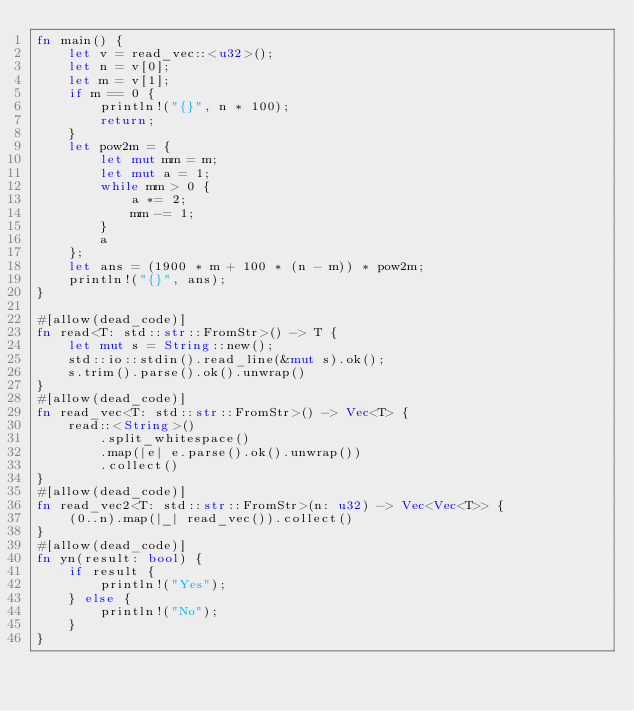Convert code to text. <code><loc_0><loc_0><loc_500><loc_500><_Rust_>fn main() {
    let v = read_vec::<u32>();
    let n = v[0];
    let m = v[1];
    if m == 0 {
        println!("{}", n * 100);
        return;
    }
    let pow2m = {
        let mut mm = m;
        let mut a = 1;
        while mm > 0 {
            a *= 2;
            mm -= 1;
        }
        a
    };
    let ans = (1900 * m + 100 * (n - m)) * pow2m;
    println!("{}", ans);
}

#[allow(dead_code)]
fn read<T: std::str::FromStr>() -> T {
    let mut s = String::new();
    std::io::stdin().read_line(&mut s).ok();
    s.trim().parse().ok().unwrap()
}
#[allow(dead_code)]
fn read_vec<T: std::str::FromStr>() -> Vec<T> {
    read::<String>()
        .split_whitespace()
        .map(|e| e.parse().ok().unwrap())
        .collect()
}
#[allow(dead_code)]
fn read_vec2<T: std::str::FromStr>(n: u32) -> Vec<Vec<T>> {
    (0..n).map(|_| read_vec()).collect()
}
#[allow(dead_code)]
fn yn(result: bool) {
    if result {
        println!("Yes");
    } else {
        println!("No");
    }
}
</code> 